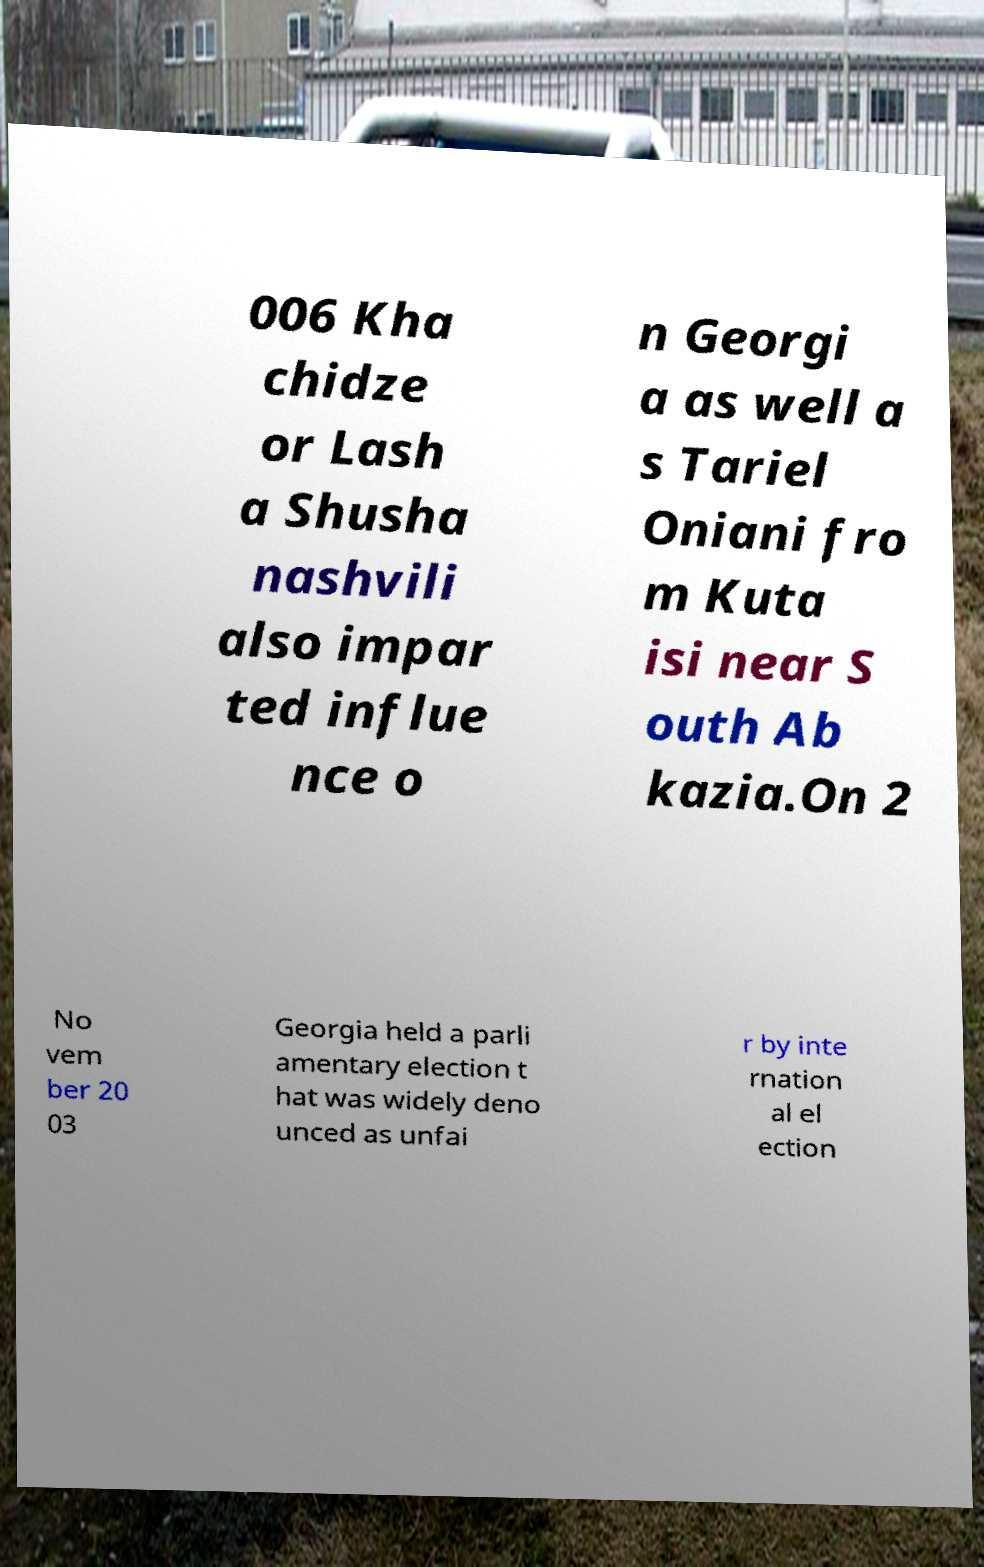Can you accurately transcribe the text from the provided image for me? 006 Kha chidze or Lash a Shusha nashvili also impar ted influe nce o n Georgi a as well a s Tariel Oniani fro m Kuta isi near S outh Ab kazia.On 2 No vem ber 20 03 Georgia held a parli amentary election t hat was widely deno unced as unfai r by inte rnation al el ection 